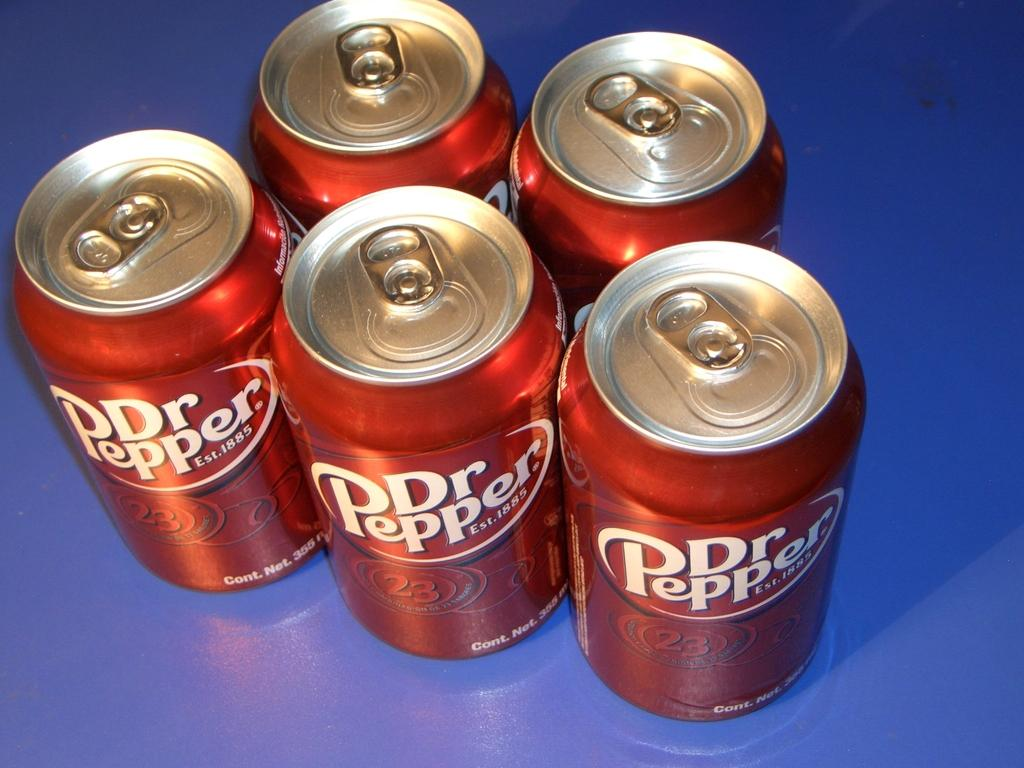Provide a one-sentence caption for the provided image. Five Dr. Pepper cans are displayed on a counter. 